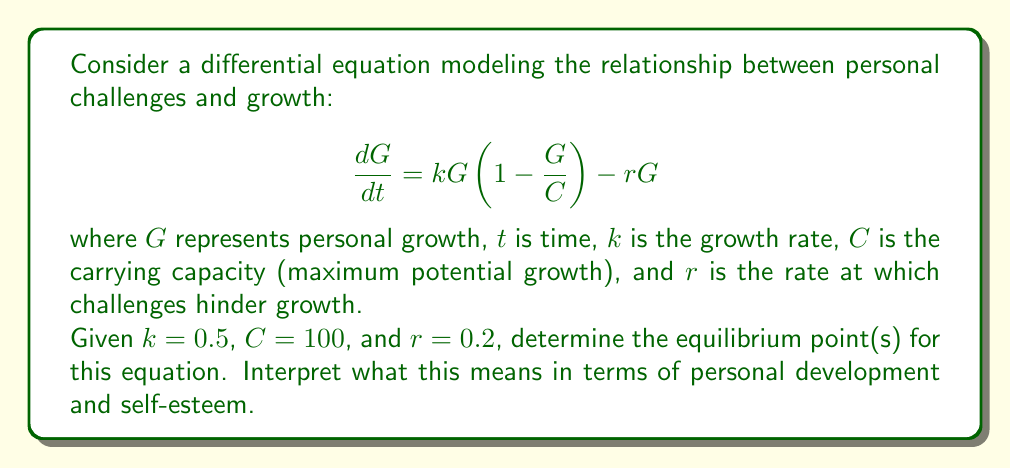Can you answer this question? To find the equilibrium point(s), we need to set $\frac{dG}{dt} = 0$ and solve for $G$:

$$0 = kG(1 - \frac{G}{C}) - rG$$

Substituting the given values:

$$0 = 0.5G(1 - \frac{G}{100}) - 0.2G$$

Simplifying:

$$0 = 0.5G - 0.005G^2 - 0.2G$$
$$0 = 0.3G - 0.005G^2$$

Factoring out $G$:

$$G(0.3 - 0.005G) = 0$$

This equation has two solutions:

1. $G = 0$
2. $0.3 - 0.005G = 0$

Solving the second equation:

$$0.005G = 0.3$$
$$G = 60$$

Therefore, the equilibrium points are $G = 0$ and $G = 60$.

Interpretation:
1. $G = 0$ represents a state of no personal growth. This is an unstable equilibrium, as any small positive growth will lead to further development.
2. $G = 60$ represents a stable equilibrium where personal growth balances with challenges. This point suggests that an individual can achieve significant personal development (60% of their maximum potential) while managing life's challenges.

In terms of personal development and self-esteem, this model suggests that:
1. Growth is possible and sustainable, even in the face of challenges.
2. There's a natural balance point where growth stabilizes, indicating that continuous, unbounded growth might not be realistic or necessary.
3. The stable equilibrium at 60% of maximum potential implies that maintaining a good level of personal growth and self-esteem is achievable without needing to reach 100% of one's theoretical maximum.
Answer: The equilibrium points are $G = 0$ and $G = 60$. The stable equilibrium at $G = 60$ represents a balance between personal growth and challenges, suggesting that sustainable personal development can be achieved at 60% of maximum potential. 